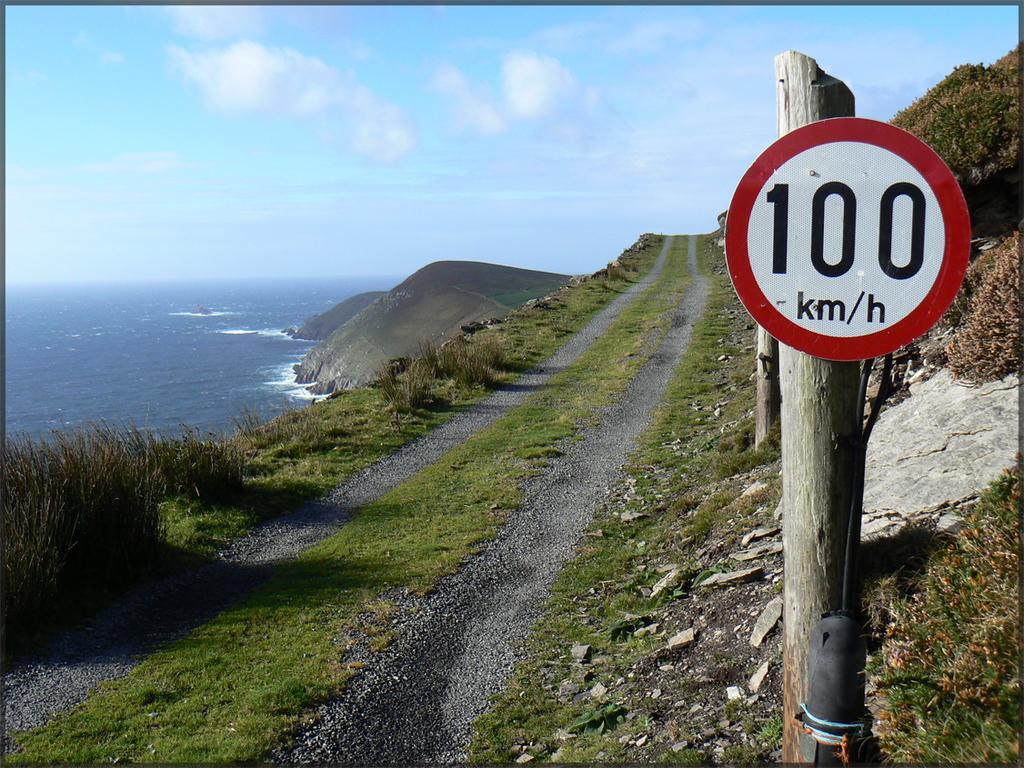<image>
Provide a brief description of the given image. The speed limit on the dirt road is 100 kilometers per hour 